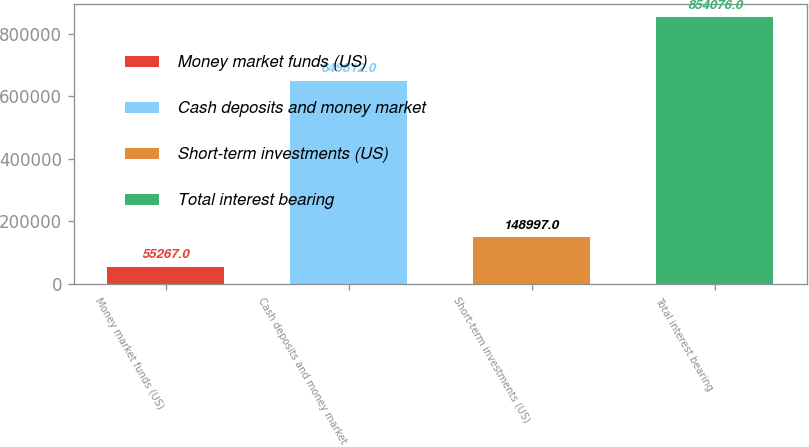Convert chart to OTSL. <chart><loc_0><loc_0><loc_500><loc_500><bar_chart><fcel>Money market funds (US)<fcel>Cash deposits and money market<fcel>Short-term investments (US)<fcel>Total interest bearing<nl><fcel>55267<fcel>649812<fcel>148997<fcel>854076<nl></chart> 